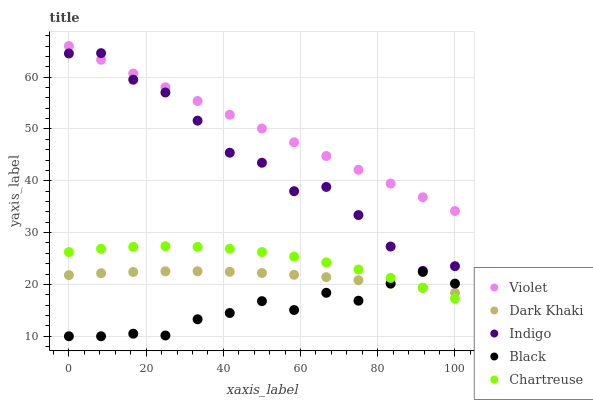Does Black have the minimum area under the curve?
Answer yes or no. Yes. Does Violet have the maximum area under the curve?
Answer yes or no. Yes. Does Chartreuse have the minimum area under the curve?
Answer yes or no. No. Does Chartreuse have the maximum area under the curve?
Answer yes or no. No. Is Violet the smoothest?
Answer yes or no. Yes. Is Indigo the roughest?
Answer yes or no. Yes. Is Black the smoothest?
Answer yes or no. No. Is Black the roughest?
Answer yes or no. No. Does Black have the lowest value?
Answer yes or no. Yes. Does Chartreuse have the lowest value?
Answer yes or no. No. Does Violet have the highest value?
Answer yes or no. Yes. Does Chartreuse have the highest value?
Answer yes or no. No. Is Black less than Indigo?
Answer yes or no. Yes. Is Indigo greater than Dark Khaki?
Answer yes or no. Yes. Does Black intersect Chartreuse?
Answer yes or no. Yes. Is Black less than Chartreuse?
Answer yes or no. No. Is Black greater than Chartreuse?
Answer yes or no. No. Does Black intersect Indigo?
Answer yes or no. No. 